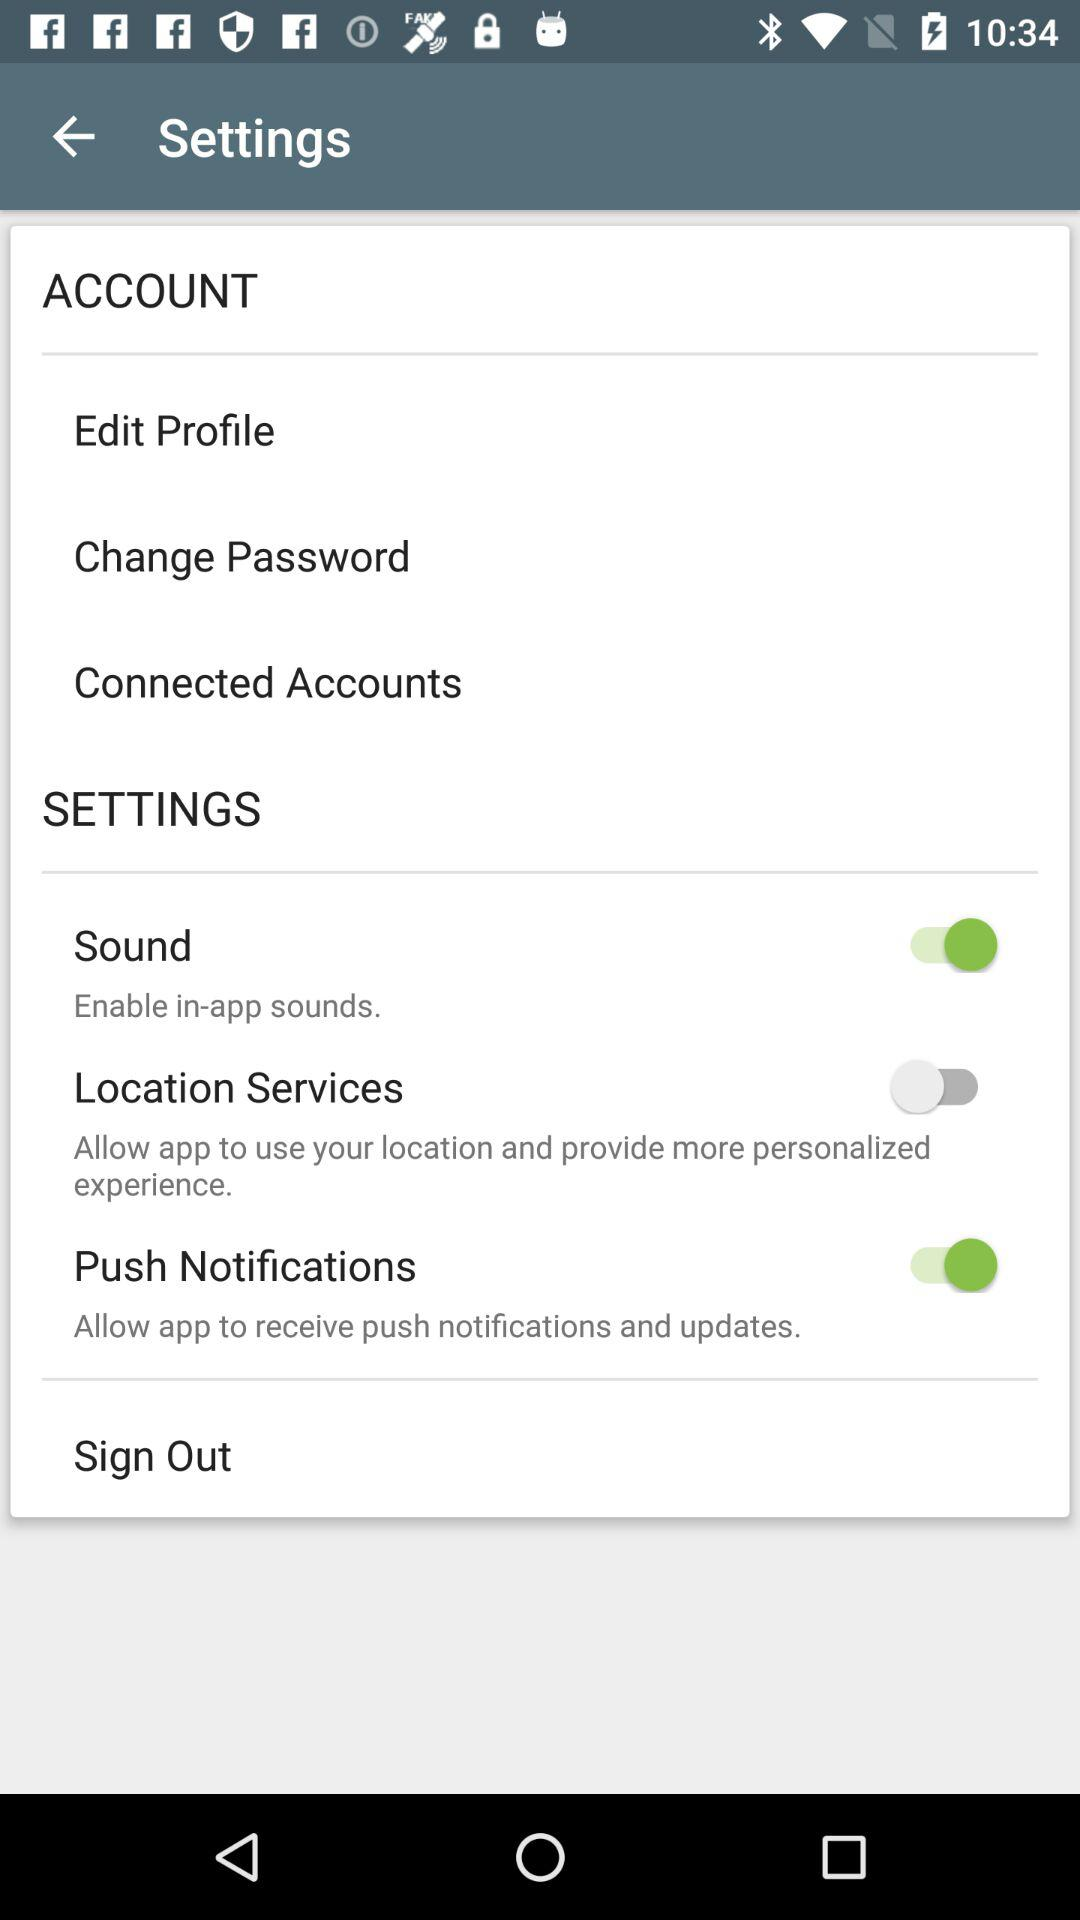What is the status of push notifications? The status is "on". 